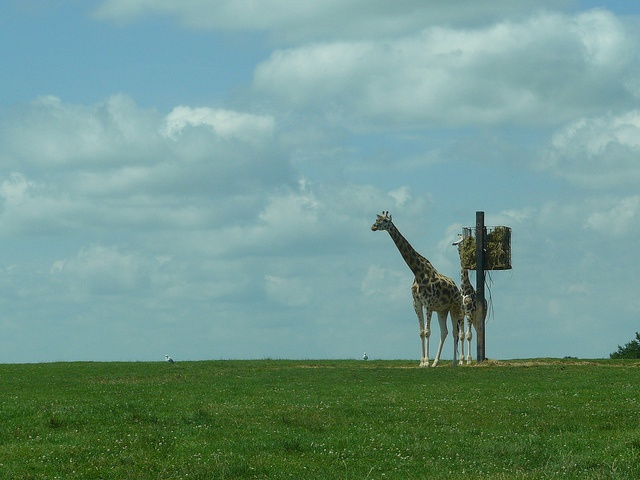Describe the objects in this image and their specific colors. I can see giraffe in lightblue, black, gray, darkgray, and darkgreen tones and giraffe in lightblue, gray, black, darkgreen, and darkgray tones in this image. 